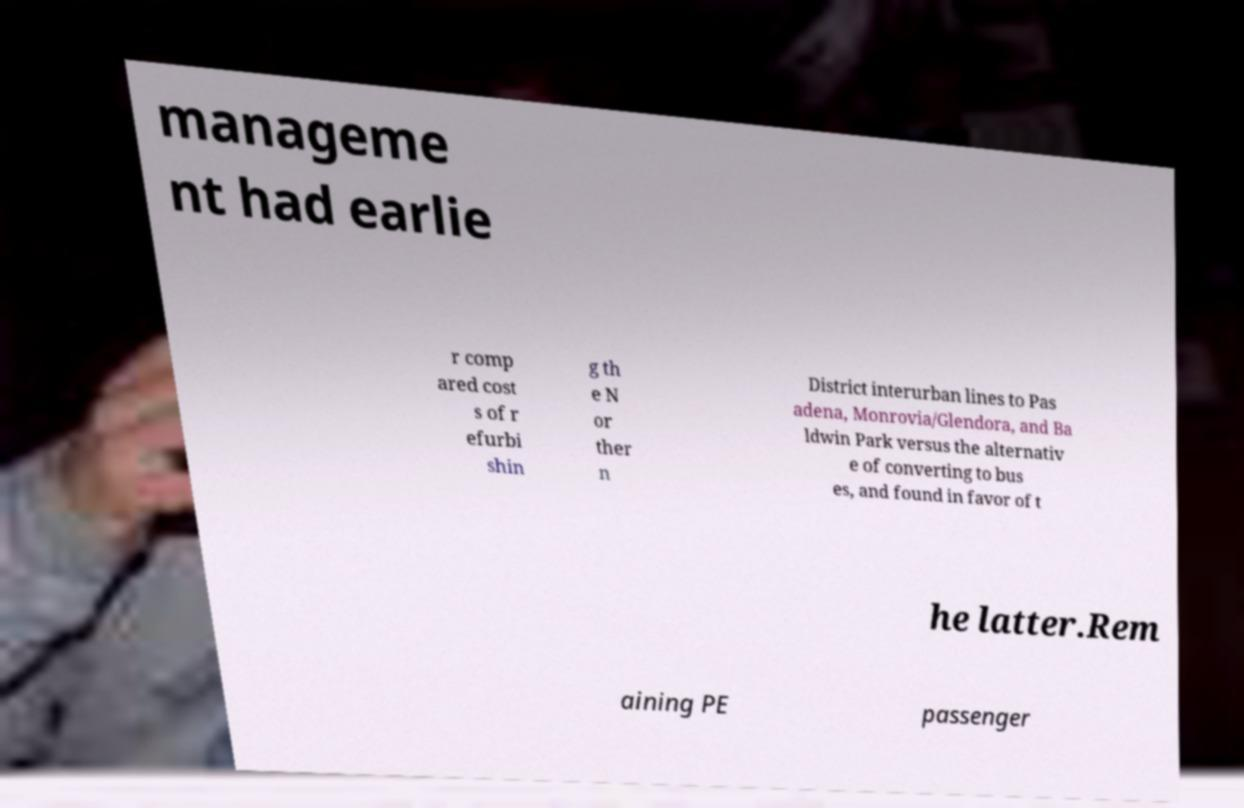Can you accurately transcribe the text from the provided image for me? manageme nt had earlie r comp ared cost s of r efurbi shin g th e N or ther n District interurban lines to Pas adena, Monrovia/Glendora, and Ba ldwin Park versus the alternativ e of converting to bus es, and found in favor of t he latter.Rem aining PE passenger 